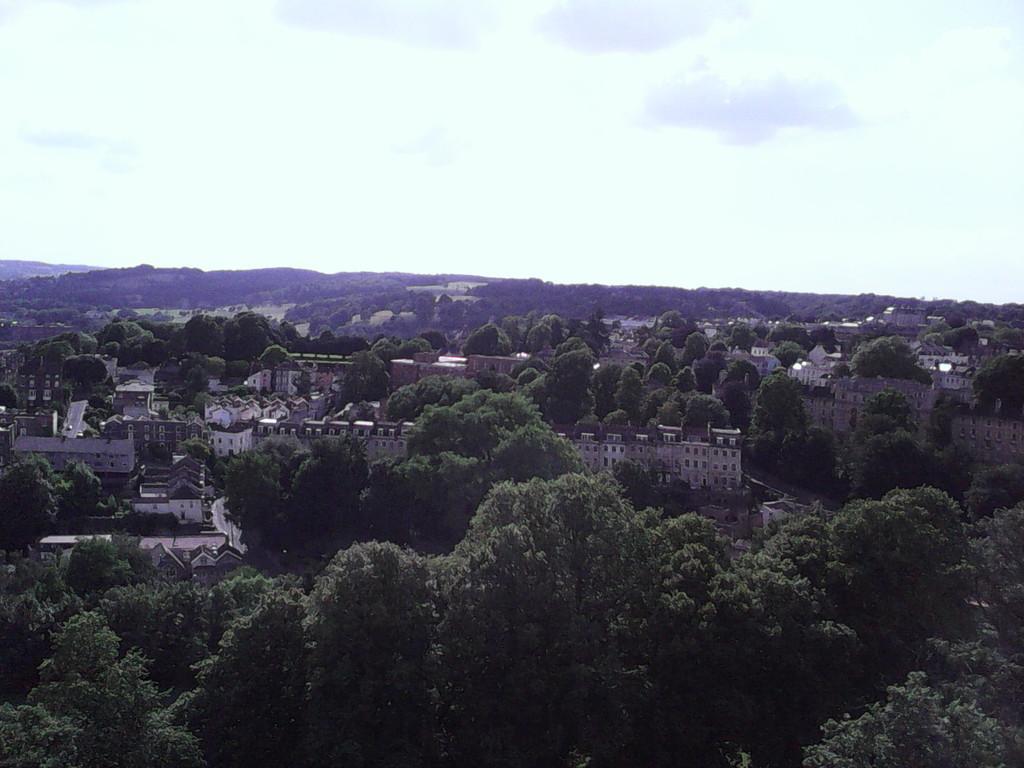How would you summarize this image in a sentence or two? In this picture we can see few trees and buildings, in the background we can find clouds. 